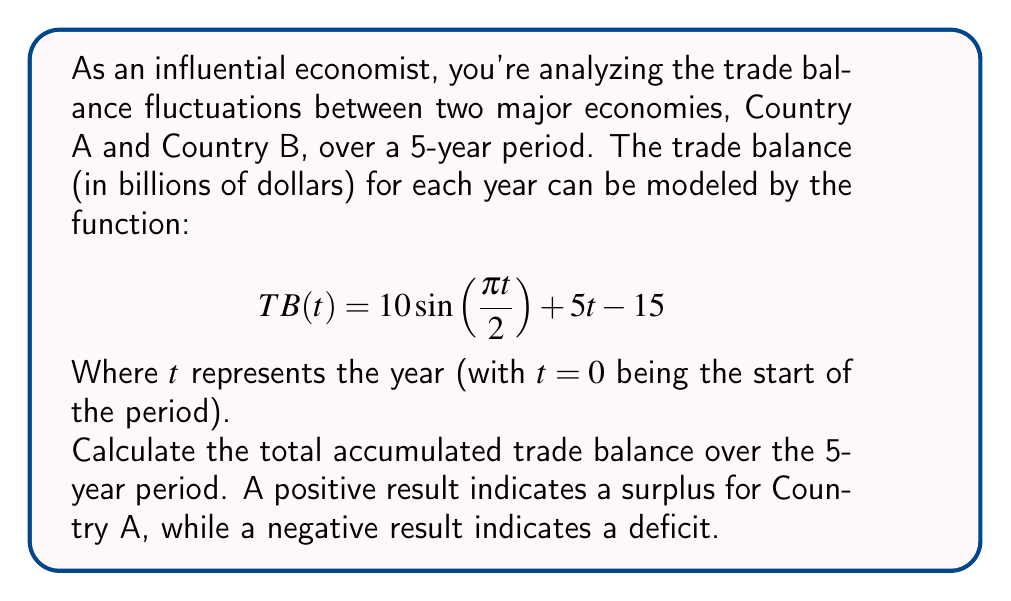Show me your answer to this math problem. To solve this problem, we need to calculate the definite integral of the trade balance function over the 5-year period. This will give us the accumulated trade balance.

1) The integral we need to calculate is:

   $$\int_0^5 TB(t) dt = \int_0^5 (10\sin(\frac{\pi t}{2}) + 5t - 15) dt$$

2) Let's integrate each term separately:

   a) $\int_0^5 10\sin(\frac{\pi t}{2}) dt$
      Let $u = \frac{\pi t}{2}$, then $du = \frac{\pi}{2} dt$ and $dt = \frac{2}{\pi} du$
      $$= \frac{20}{\pi} \int_0^{\frac{5\pi}{2}} \sin(u) du = -\frac{20}{\pi} [\cos(u)]_0^{\frac{5\pi}{2}} = -\frac{20}{\pi} (\cos(\frac{5\pi}{2}) - \cos(0)) = -\frac{20}{\pi} (-1 - 1) = \frac{40}{\pi}$$

   b) $\int_0^5 5t dt = [\frac{5t^2}{2}]_0^5 = \frac{125}{2} - 0 = \frac{125}{2}$

   c) $\int_0^5 -15 dt = [-15t]_0^5 = -75$

3) Sum up all the parts:

   $$\frac{40}{\pi} + \frac{125}{2} - 75 = \frac{40}{\pi} + 62.5 - 75 = \frac{40}{\pi} - 12.5$$

4) Calculate the final value:

   $$\frac{40}{\pi} - 12.5 \approx 0.2337$$
Answer: The total accumulated trade balance over the 5-year period is approximately $0.2337$ billion dollars, indicating a small surplus for Country A. 